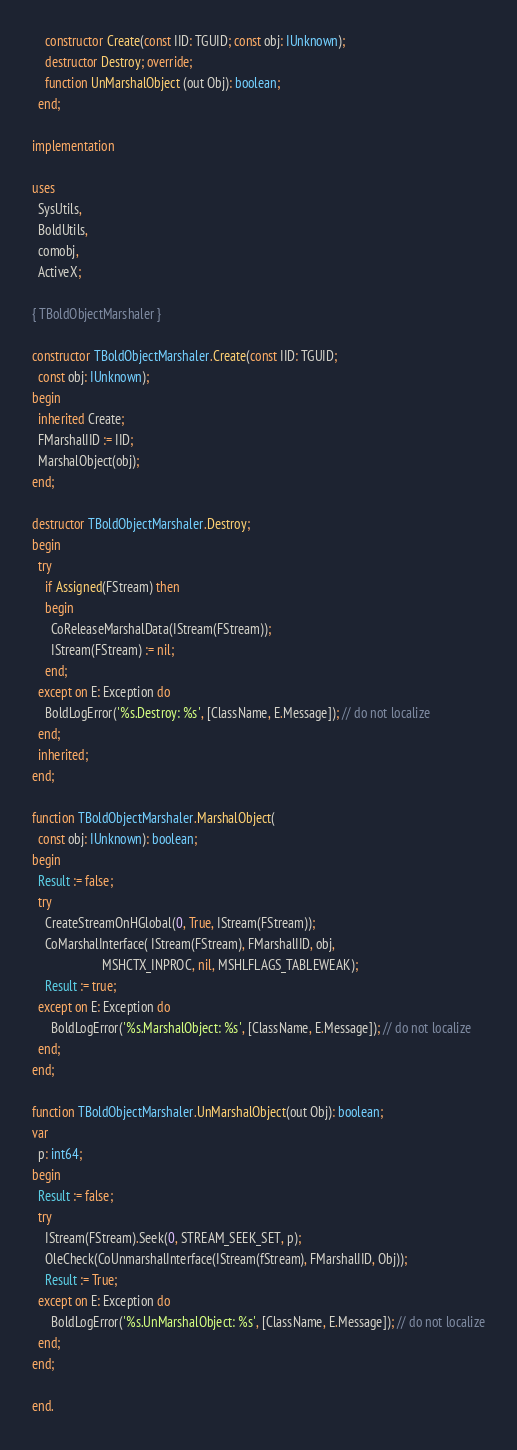Convert code to text. <code><loc_0><loc_0><loc_500><loc_500><_Pascal_>    constructor Create(const IID: TGUID; const obj: IUnknown);
    destructor Destroy; override;
    function UnMarshalObject (out Obj): boolean;
  end;

implementation

uses
  SysUtils,
  BoldUtils,
  comobj,
  ActiveX;

{ TBoldObjectMarshaler }

constructor TBoldObjectMarshaler.Create(const IID: TGUID;
  const obj: IUnknown);
begin
  inherited Create;
  FMarshalIID := IID;
  MarshalObject(obj);
end;

destructor TBoldObjectMarshaler.Destroy;
begin
  try
    if Assigned(FStream) then
    begin
      CoReleaseMarshalData(IStream(FStream));
      IStream(FStream) := nil;
    end;
  except on E: Exception do
    BoldLogError('%s.Destroy: %s', [ClassName, E.Message]); // do not localize
  end;
  inherited;
end;

function TBoldObjectMarshaler.MarshalObject(
  const obj: IUnknown): boolean;
begin
  Result := false;
  try
    CreateStreamOnHGlobal(0, True, IStream(FStream));
    CoMarshalInterface( IStream(FStream), FMarshalIID, obj,
                      MSHCTX_INPROC, nil, MSHLFLAGS_TABLEWEAK);
    Result := true;
  except on E: Exception do
      BoldLogError('%s.MarshalObject: %s', [ClassName, E.Message]); // do not localize
  end;
end;

function TBoldObjectMarshaler.UnMarshalObject(out Obj): boolean;
var
  p: int64;
begin
  Result := false;
  try
    IStream(FStream).Seek(0, STREAM_SEEK_SET, p);
    OleCheck(CoUnmarshalInterface(IStream(fStream), FMarshalIID, Obj));
    Result := True;
  except on E: Exception do
      BoldLogError('%s.UnMarshalObject: %s', [ClassName, E.Message]); // do not localize
  end;
end;

end.
</code> 